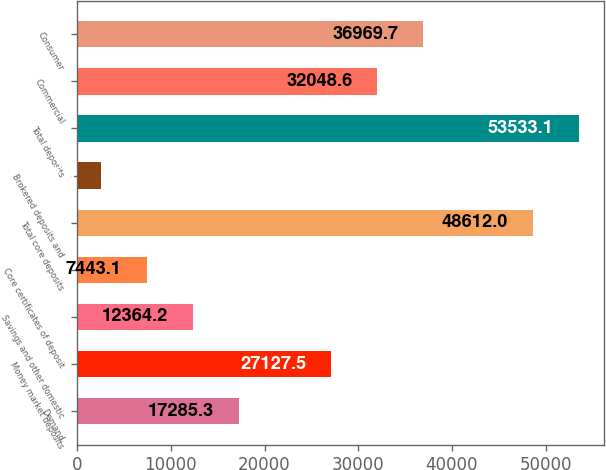Convert chart. <chart><loc_0><loc_0><loc_500><loc_500><bar_chart><fcel>Demand<fcel>Money market deposits<fcel>Savings and other domestic<fcel>Core certificates of deposit<fcel>Total core deposits<fcel>Brokered deposits and<fcel>Total deposits<fcel>Commercial<fcel>Consumer<nl><fcel>17285.3<fcel>27127.5<fcel>12364.2<fcel>7443.1<fcel>48612<fcel>2522<fcel>53533.1<fcel>32048.6<fcel>36969.7<nl></chart> 